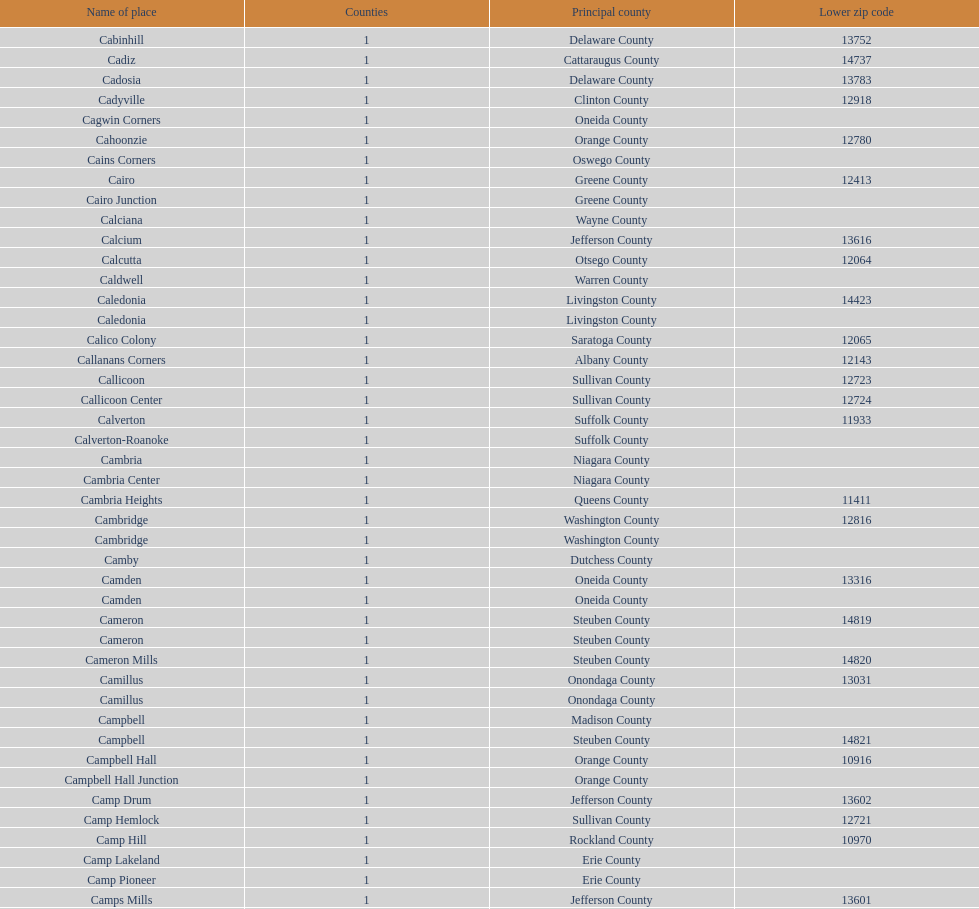How many places are in greene county? 10. 